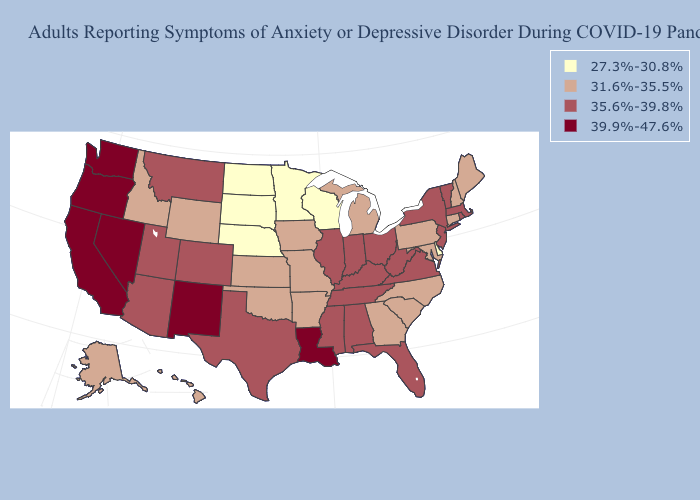Does Hawaii have a lower value than Wyoming?
Short answer required. No. How many symbols are there in the legend?
Write a very short answer. 4. What is the value of Tennessee?
Answer briefly. 35.6%-39.8%. Does Delaware have the lowest value in the USA?
Short answer required. Yes. Which states have the highest value in the USA?
Answer briefly. California, Louisiana, Nevada, New Mexico, Oregon, Washington. Does Mississippi have a lower value than Colorado?
Answer briefly. No. What is the value of Nebraska?
Write a very short answer. 27.3%-30.8%. Name the states that have a value in the range 31.6%-35.5%?
Concise answer only. Alaska, Arkansas, Connecticut, Georgia, Hawaii, Idaho, Iowa, Kansas, Maine, Maryland, Michigan, Missouri, New Hampshire, North Carolina, Oklahoma, Pennsylvania, South Carolina, Wyoming. Does Arizona have the highest value in the West?
Write a very short answer. No. Name the states that have a value in the range 27.3%-30.8%?
Short answer required. Delaware, Minnesota, Nebraska, North Dakota, South Dakota, Wisconsin. Name the states that have a value in the range 35.6%-39.8%?
Concise answer only. Alabama, Arizona, Colorado, Florida, Illinois, Indiana, Kentucky, Massachusetts, Mississippi, Montana, New Jersey, New York, Ohio, Rhode Island, Tennessee, Texas, Utah, Vermont, Virginia, West Virginia. Does Massachusetts have the highest value in the Northeast?
Answer briefly. Yes. Which states have the lowest value in the Northeast?
Give a very brief answer. Connecticut, Maine, New Hampshire, Pennsylvania. Name the states that have a value in the range 39.9%-47.6%?
Write a very short answer. California, Louisiana, Nevada, New Mexico, Oregon, Washington. What is the highest value in states that border Nebraska?
Quick response, please. 35.6%-39.8%. 